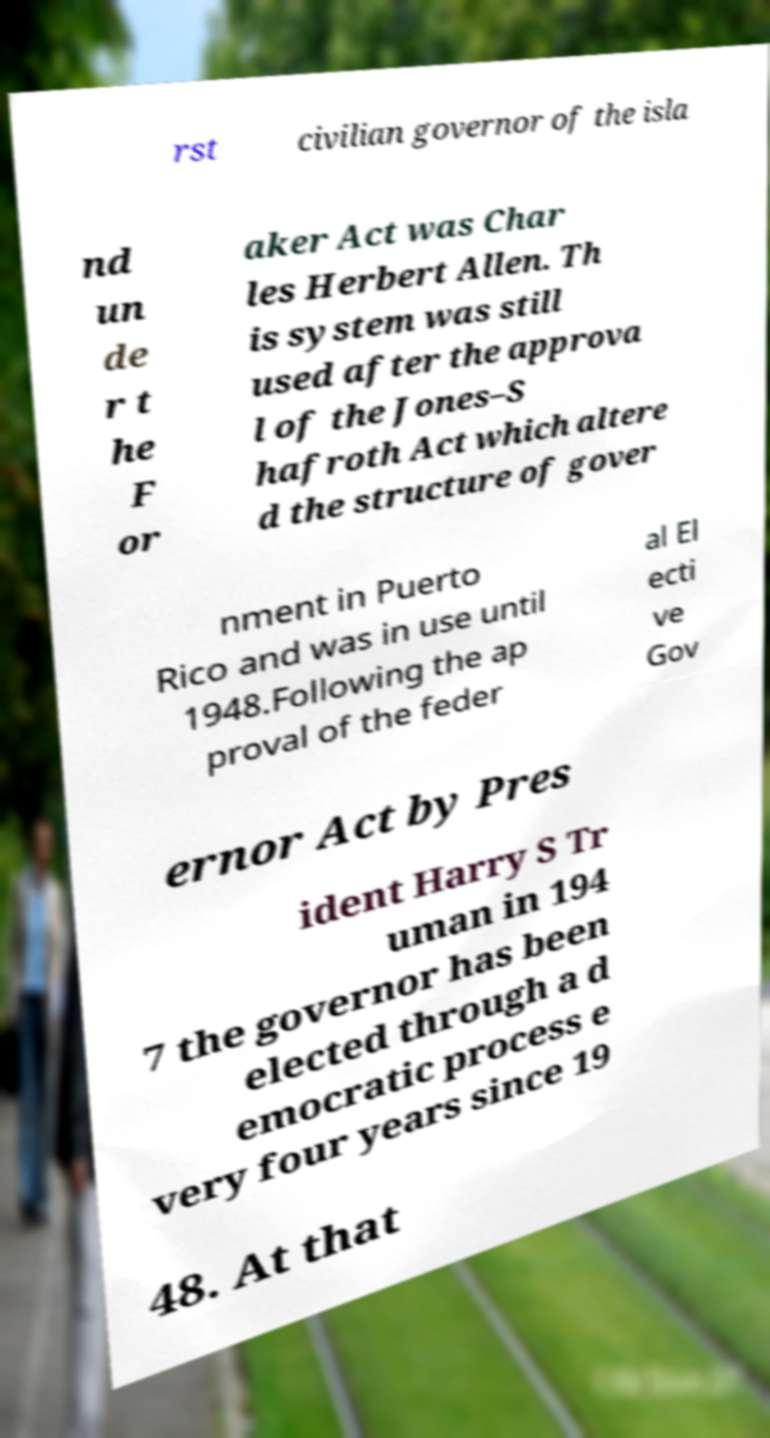Please identify and transcribe the text found in this image. rst civilian governor of the isla nd un de r t he F or aker Act was Char les Herbert Allen. Th is system was still used after the approva l of the Jones–S hafroth Act which altere d the structure of gover nment in Puerto Rico and was in use until 1948.Following the ap proval of the feder al El ecti ve Gov ernor Act by Pres ident Harry S Tr uman in 194 7 the governor has been elected through a d emocratic process e very four years since 19 48. At that 